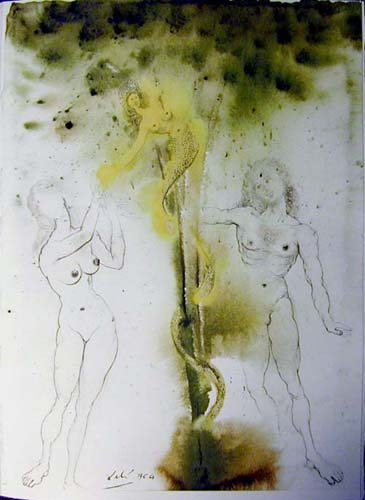How do the colors used in the background contribute to the mood of the scene? The green and yellow hues in the background imbue the scene with an otherworldly, dreamlike quality. Green often symbolizes growth and harmony, while yellow can evoke feelings of energy and warmth. Together, they create a surreal, comforting yet uncanny atmosphere that enhances the fantastical elements of the image. 